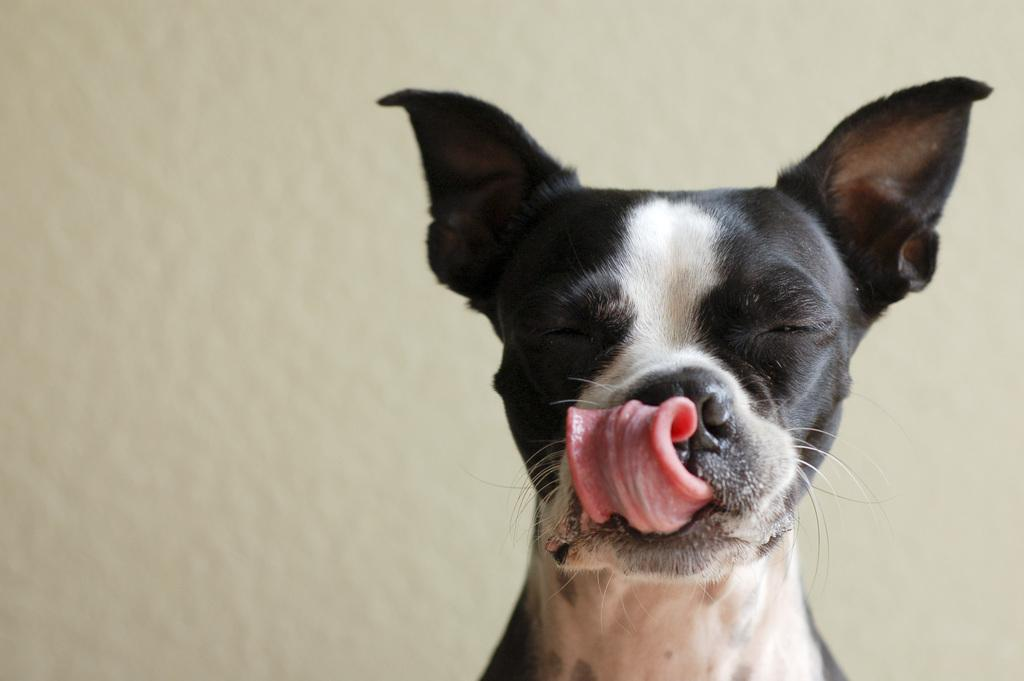What animal can be seen in the picture? There is a dog in the picture. What is the dog doing in the picture? The dog is licking its nose. What color is the background of the image? The background of the image is white. What type of agreement is being signed by the beetle in the image? There is no beetle present in the image, and therefore no agreement being signed. 